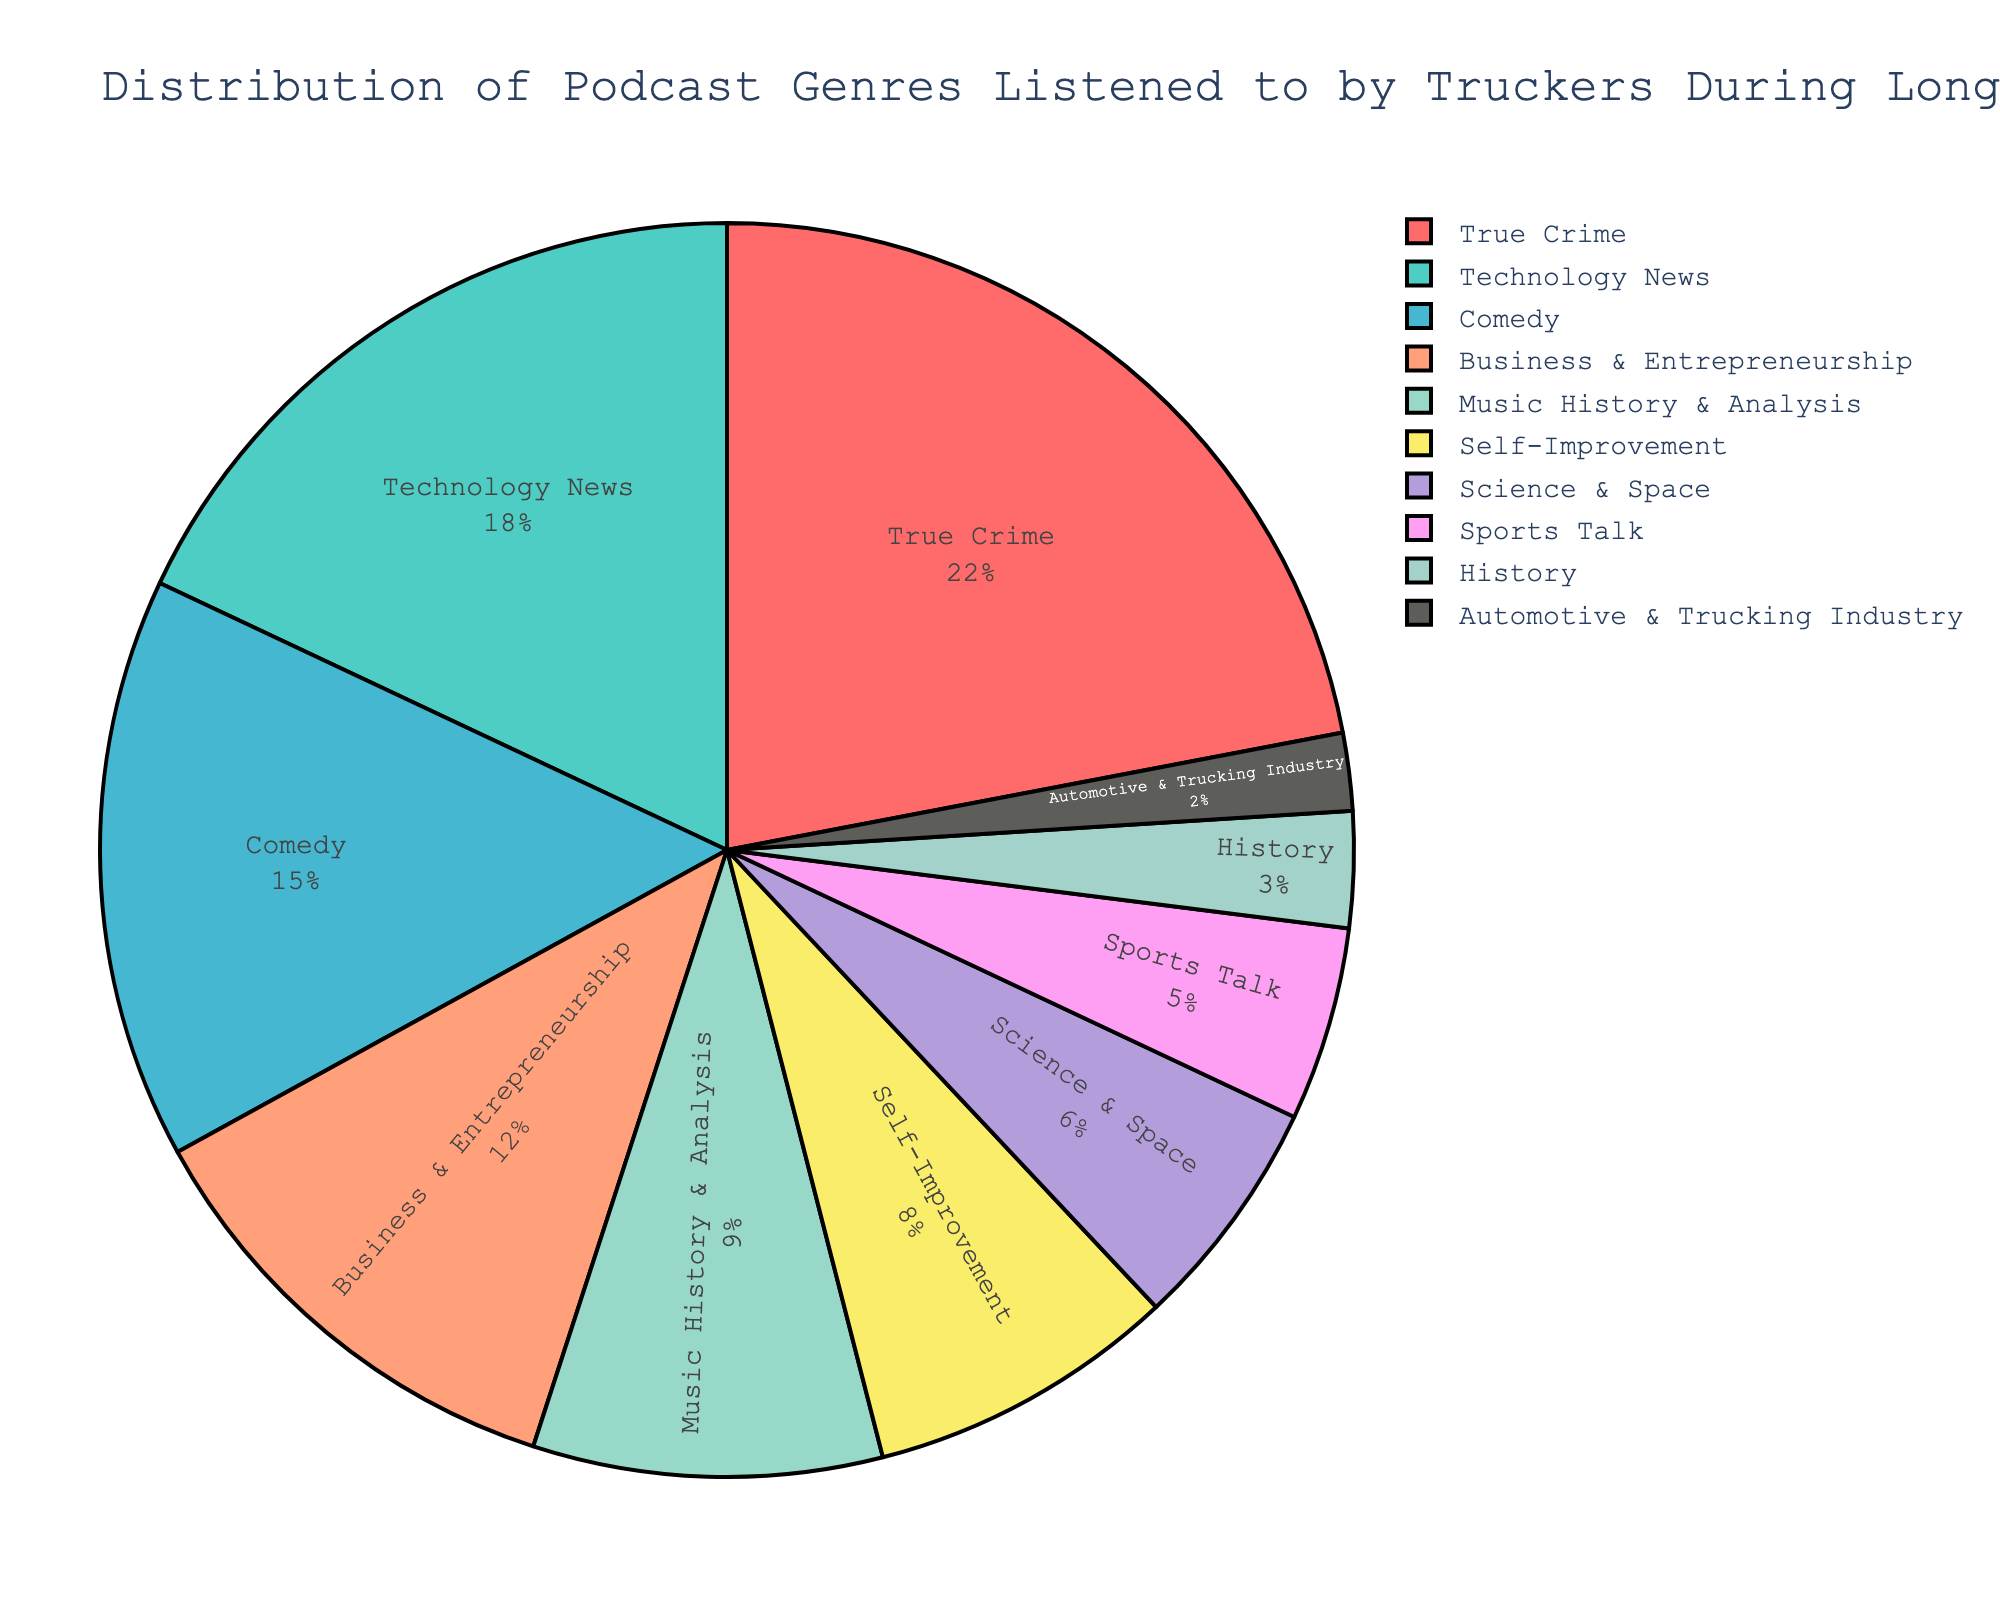What's the most popular podcast genre among truckers? From the pie chart, the largest slice represents the genre with the highest percentage, which is "True Crime" with 22%.
Answer: True Crime What percentage of truckers listen to Technology News podcasts? The pie chart shows the percentage for each genre. The slice for Technology News is labeled with 18%.
Answer: 18% Which genre has a larger share, Comedy or Business & Entrepreneurship? Comparing the sizes and labels of the slices, Comedy stands at 15% while Business & Entrepreneurship is at 12%. 15% is larger than 12%.
Answer: Comedy What is the combined percentage of truckers who listen to Science & Space and Self-Improvement podcasts? Add the percentages for Science & Space (6%) and Self-Improvement (8%). 6 + 8 = 14
Answer: 14% How much smaller is the percentage of Automotive & Trucking Industry podcasts compared to Sports Talk? Subtract the percentage of Automotive & Trucking Industry (2%) from Sports Talk (5%). 5 - 2 = 3
Answer: 3% Which genres have a share of 10% or more? Identify slices with percentages of 10 or higher. True Crime (22%), Technology News (18%), Comedy (15%), and Business & Entrepreneurship (12%) meet this criterion.
Answer: True Crime, Technology News, Comedy, Business & Entrepreneurship What is the least popular podcast genre among truckers? The smallest slice represents the genre with the lowest percentage, which is "Automotive & Trucking Industry" at 2%.
Answer: Automotive & Trucking Industry How many genres have a share less than 10%? Count the slices with fewer than 10%. Music History & Analysis (9%), Self-Improvement (8%), Science & Space (6%), Sports Talk (5%), History (3%), and Automotive & Trucking Industry (2%) are under 10%. Thus, there are 6 genres.
Answer: 6 What percentage of truckers listen to either History or Sports Talk podcasts? Add the percentages for History (3%) and Sports Talk (5%). 3 + 5 = 8
Answer: 8% By how much does the percentage of True Crime podcasts exceed that of Music History & Analysis? Subtract the percentage of Music History & Analysis (9%) from True Crime (22%). 22 - 9 = 13
Answer: 13 